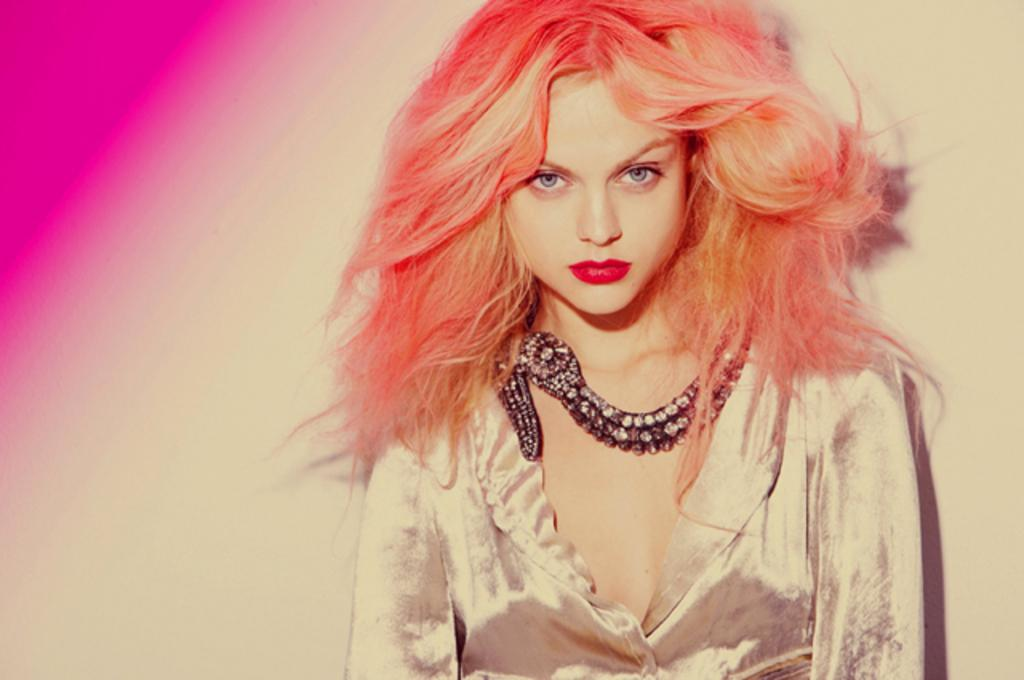Who is the main subject in the image? There is a woman in the image. What is a distinctive feature of the woman's appearance? The woman has orange hair. Can you describe any colors visible in the image? There is a pink color visible in the image, likely in the left corner. What type of guitar is the secretary playing in the image? There is no guitar or secretary present in the image. What color is the sock on the woman's foot in the image? There is no sock visible in the image, and the woman's feet are not shown. 